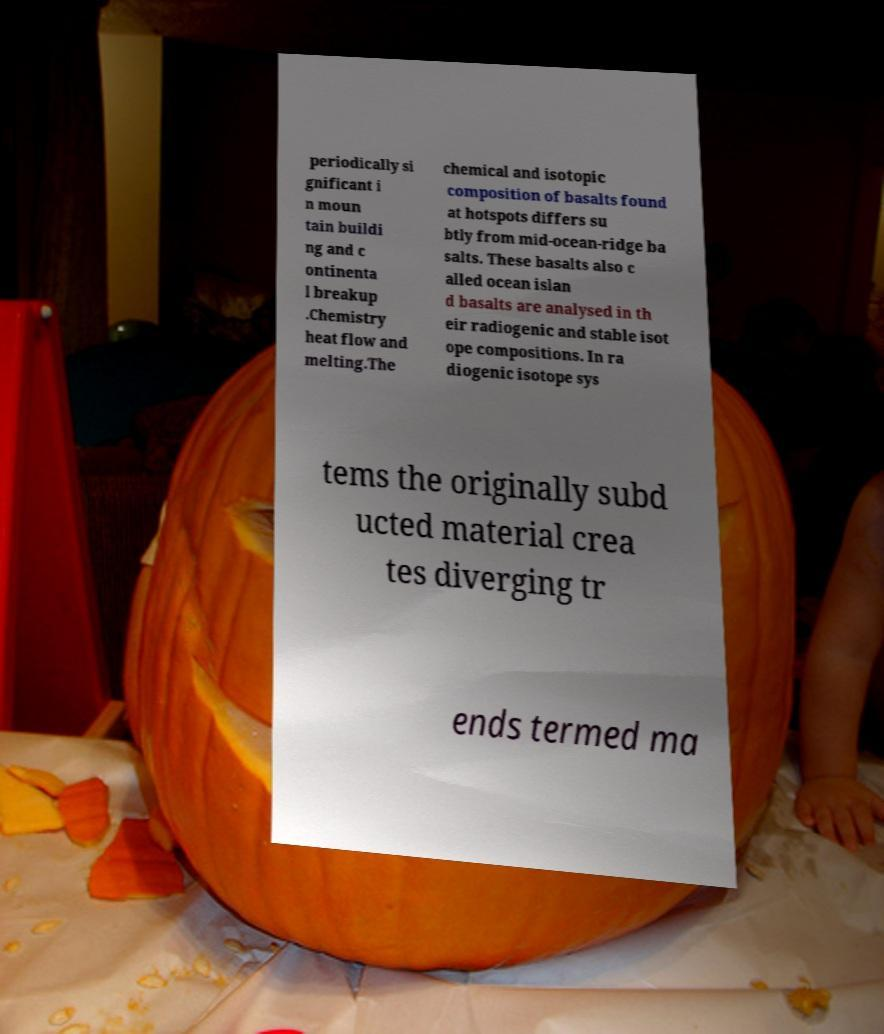I need the written content from this picture converted into text. Can you do that? periodically si gnificant i n moun tain buildi ng and c ontinenta l breakup .Chemistry heat flow and melting.The chemical and isotopic composition of basalts found at hotspots differs su btly from mid-ocean-ridge ba salts. These basalts also c alled ocean islan d basalts are analysed in th eir radiogenic and stable isot ope compositions. In ra diogenic isotope sys tems the originally subd ucted material crea tes diverging tr ends termed ma 